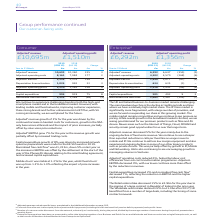According to Bt Group Plc's financial document, What is the main challenge faced by the company? The main headwind we face is the decline in traditional calls and lines where we have a relatively high market share.. The document states: "d business-to-business market remains challenging. The main headwind we face is the decline in traditional calls and lines where we have a relatively ..." Also, What is the decrease in adjusted revenue? According to the financial document, 5%. The relevant text states: "019. Normalised free cash flow b was £1,323m, down 5% on last year as the increase in EBITDA was offset by the settlement at the start of the year of the..." Also, What caused the decrease in retail order? due to the signing of a large contract in Republic of Ireland in the prior year.. The document states: "order intake decreased 15% to £2.9bn for the year due to the signing of a large contract in Republic of Ireland in the prior year. The Wholesale order..." Also, can you calculate: What was the percentage change in the Adjusted a revenue from 2018 to 2019? To answer this question, I need to perform calculations using the financial data. The calculation is: 6,292 / 6,647 - 1, which equals -5.34 (percentage). This is based on the information: "Adjusted a revenue 6,292 6,647 (355) (5) Adjusted a revenue 6,292 6,647 (355) (5)..." The key data points involved are: 6,292, 6,647. Also, can you calculate: What is the average Adjusted a operating costs for 2018 and 2019? To answer this question, I need to perform calculations using the financial data. The calculation is: (4,302 + 4,570) / 2, which equals 4436 (in millions). This is based on the information: "Adjusted a operating costs 4,302 4,570 (268) (6) Adjusted a operating costs 4,302 4,570 (268) (6)..." The key data points involved are: 4,302, 4,570. Also, can you calculate: What is the EBITDA margin in 2019? Based on the calculation: 1,990 / 6,292, the result is 0.32. This is based on the information: "Adjusted a EBITDA 1,990 2,077 (87) (4) Adjusted a revenue 6,292 6,647 (355) (5)..." The key data points involved are: 1,990, 6,292. 